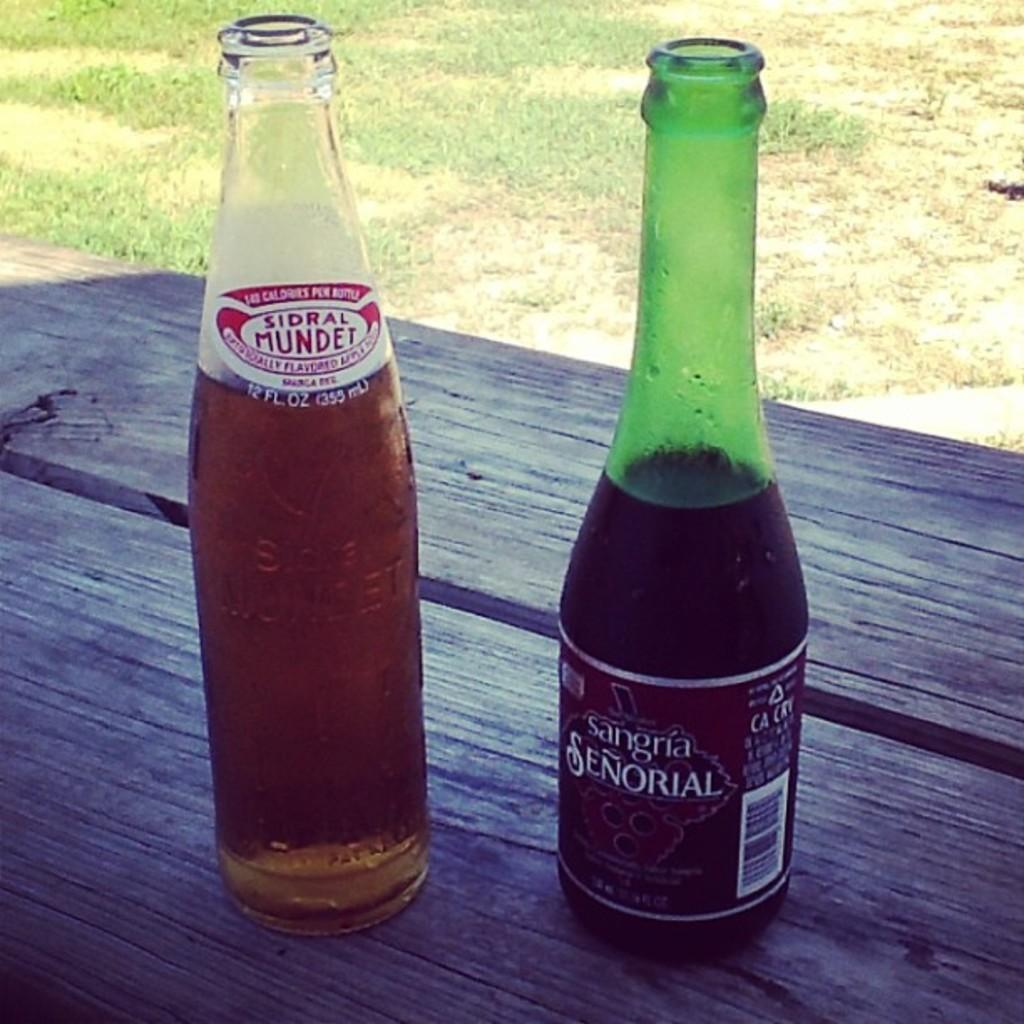What type of furniture is present in the image? There is a table in the image. What color is the table? The table is black. What objects are on the table? There are two bottles on the table. What can be seen in the background of the image? There is grass in the background of the image. What is the reason for the street being present in the image? There is no street present in the image; it features a black table with two bottles and a grassy background. 